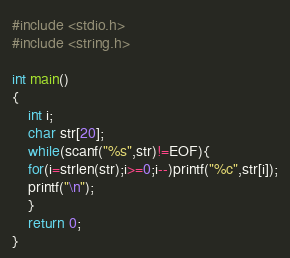<code> <loc_0><loc_0><loc_500><loc_500><_C_>#include <stdio.h>
#include <string.h>

int main()
{
	int i;
	char str[20];
	while(scanf("%s",str)!=EOF){
	for(i=strlen(str);i>=0;i--)printf("%c",str[i]);
	printf("\n");
	}
	return 0;
}</code> 